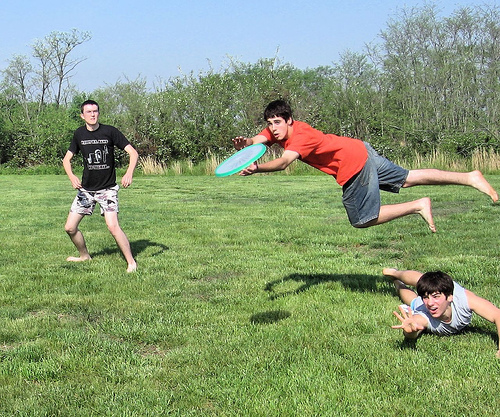Please provide the bounding box coordinate of the region this sentence describes: short green and yellow grasss. The coordinates corresponding to short green and yellow grass are approximately: [0.15, 0.68, 0.24, 0.77]. 